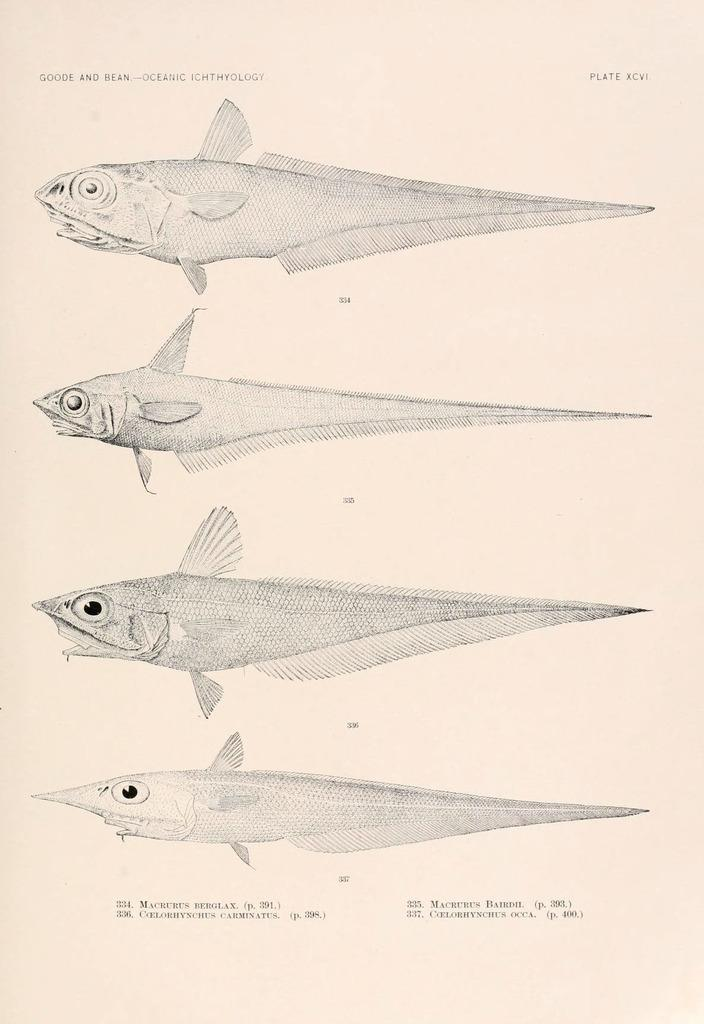What is present in the image that contains both images and text? There is a poster in the image that contains images and text. How does the leaf act in the image? There is no leaf present in the image, so it cannot act or be observed. 